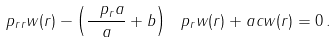<formula> <loc_0><loc_0><loc_500><loc_500>\ p _ { r r } w ( r ) - \left ( \frac { \ p _ { r } a } { a } + b \right ) \ p _ { r } w ( r ) + a c w ( r ) = 0 \, .</formula> 